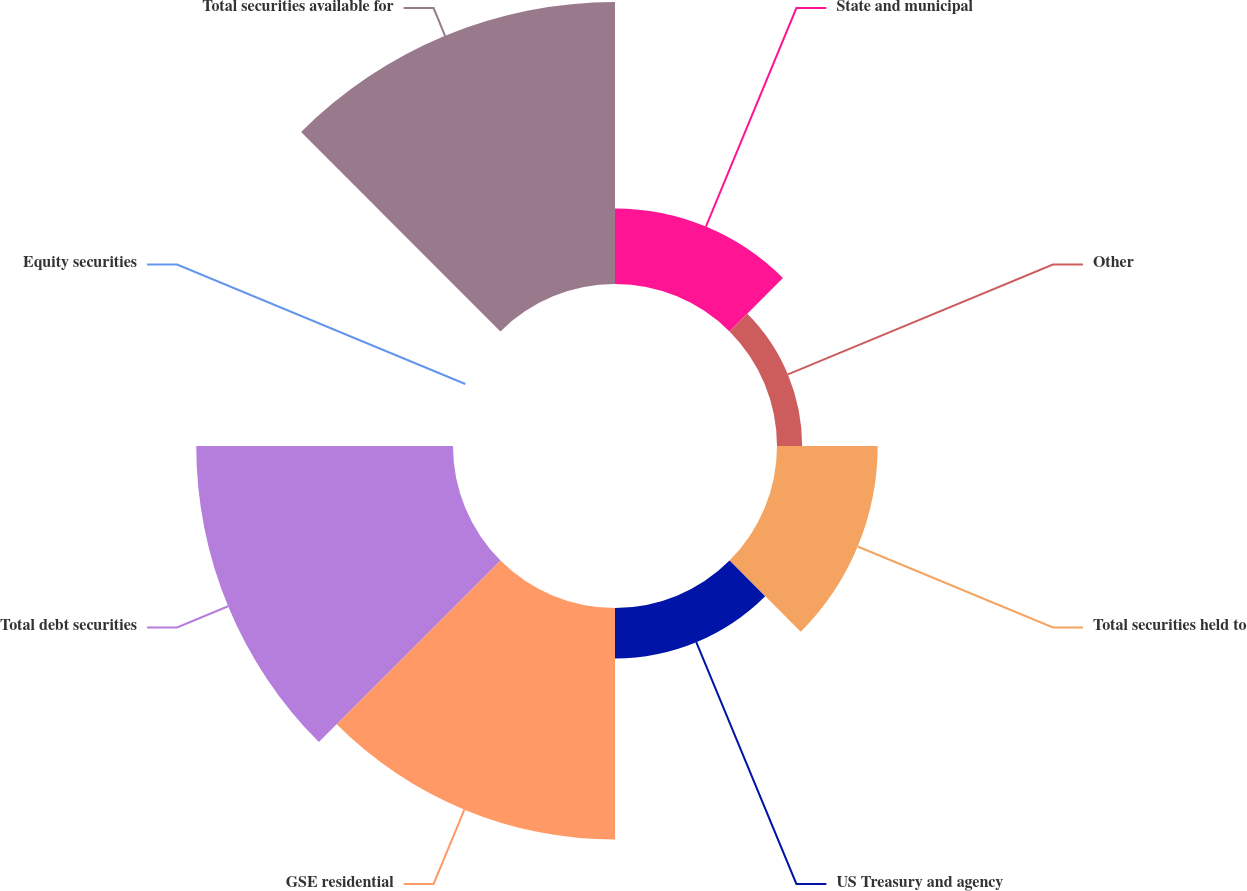<chart> <loc_0><loc_0><loc_500><loc_500><pie_chart><fcel>State and municipal<fcel>Other<fcel>Total securities held to<fcel>US Treasury and agency<fcel>GSE residential<fcel>Total debt securities<fcel>Equity securities<fcel>Total securities available for<nl><fcel>7.39%<fcel>2.46%<fcel>9.85%<fcel>4.93%<fcel>22.66%<fcel>25.12%<fcel>0.0%<fcel>27.59%<nl></chart> 